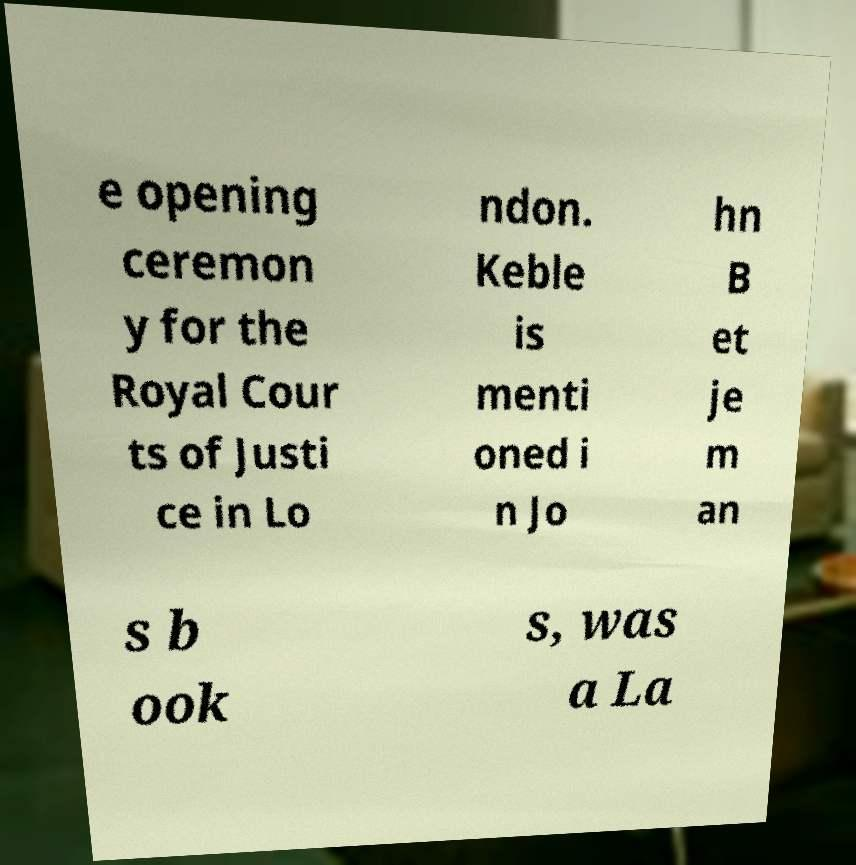Can you accurately transcribe the text from the provided image for me? e opening ceremon y for the Royal Cour ts of Justi ce in Lo ndon. Keble is menti oned i n Jo hn B et je m an s b ook s, was a La 